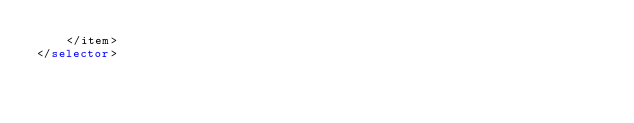Convert code to text. <code><loc_0><loc_0><loc_500><loc_500><_XML_>    </item>
</selector></code> 